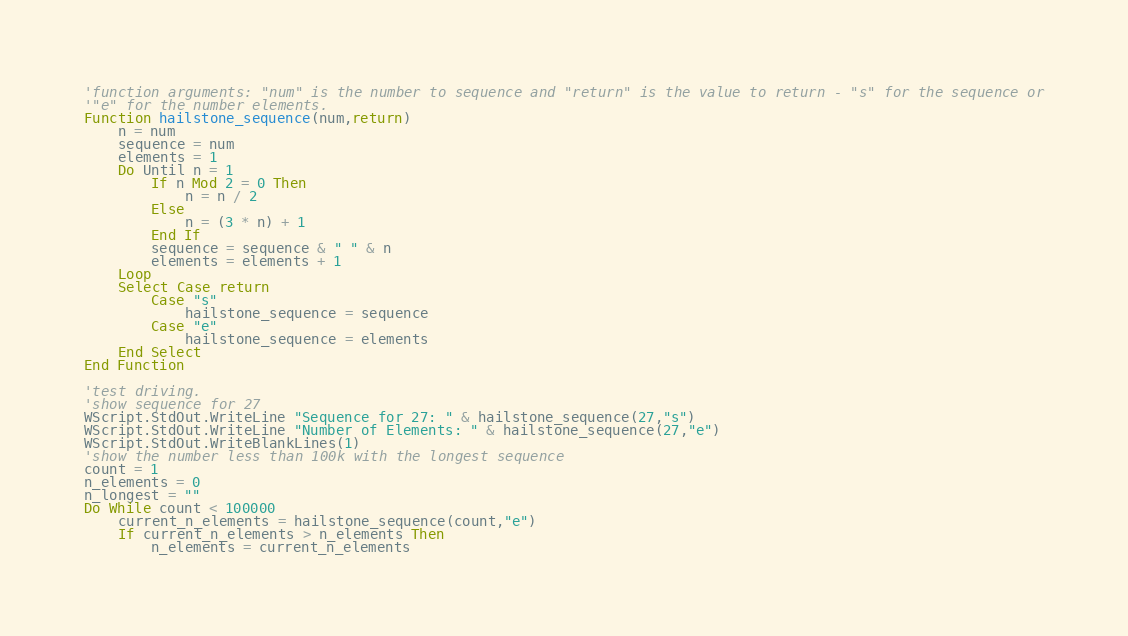Convert code to text. <code><loc_0><loc_0><loc_500><loc_500><_VisualBasic_>'function arguments: "num" is the number to sequence and "return" is the value to return - "s" for the sequence or
'"e" for the number elements.
Function hailstone_sequence(num,return)
    n = num
	sequence = num
	elements = 1
	Do Until n = 1
		If n Mod 2 = 0 Then
			n = n / 2
		Else
			n = (3 * n) + 1
		End If
		sequence = sequence & " " & n
		elements = elements + 1	
	Loop
	Select Case return
		Case "s"
			hailstone_sequence = sequence
		Case "e"
			hailstone_sequence = elements
	End Select
End Function

'test driving.
'show sequence for 27
WScript.StdOut.WriteLine "Sequence for 27: " & hailstone_sequence(27,"s")
WScript.StdOut.WriteLine "Number of Elements: " & hailstone_sequence(27,"e")
WScript.StdOut.WriteBlankLines(1)
'show the number less than 100k with the longest sequence
count = 1
n_elements = 0
n_longest = ""
Do While count < 100000
	current_n_elements = hailstone_sequence(count,"e")
	If current_n_elements > n_elements Then
		n_elements = current_n_elements</code> 